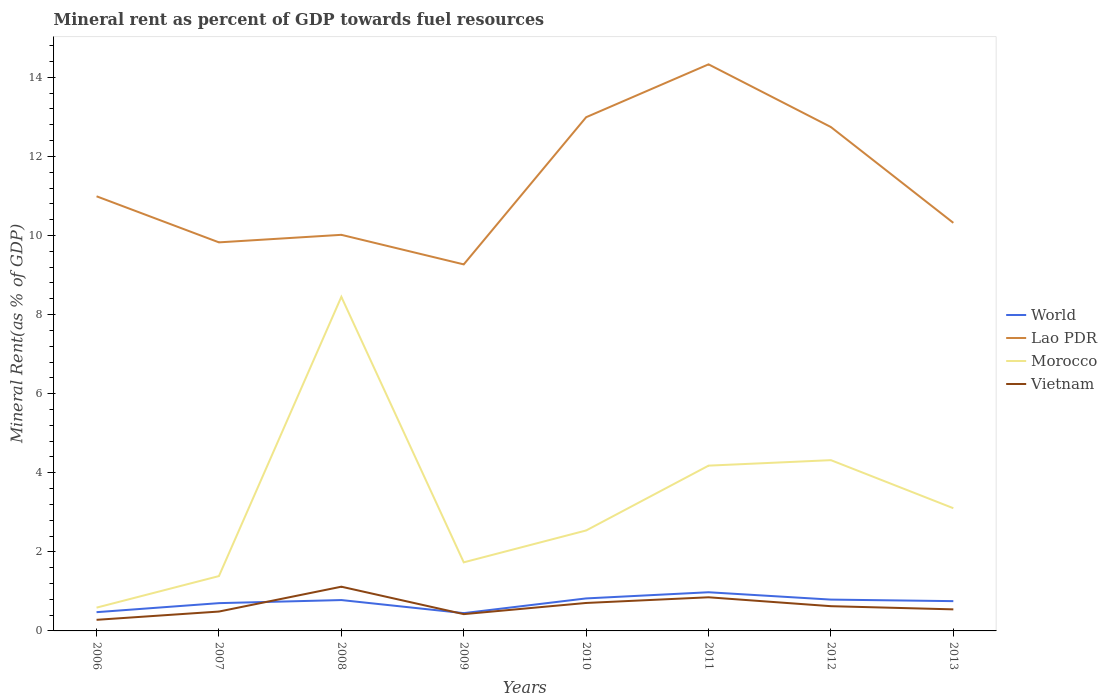How many different coloured lines are there?
Give a very brief answer. 4. Is the number of lines equal to the number of legend labels?
Make the answer very short. Yes. Across all years, what is the maximum mineral rent in Morocco?
Ensure brevity in your answer.  0.59. In which year was the mineral rent in Morocco maximum?
Your answer should be compact. 2006. What is the total mineral rent in Lao PDR in the graph?
Keep it short and to the point. -1.34. What is the difference between the highest and the second highest mineral rent in Morocco?
Your answer should be compact. 7.86. What is the difference between the highest and the lowest mineral rent in World?
Your response must be concise. 5. Is the mineral rent in Vietnam strictly greater than the mineral rent in Lao PDR over the years?
Keep it short and to the point. Yes. How many years are there in the graph?
Give a very brief answer. 8. Does the graph contain grids?
Offer a very short reply. No. How many legend labels are there?
Your answer should be very brief. 4. What is the title of the graph?
Offer a terse response. Mineral rent as percent of GDP towards fuel resources. What is the label or title of the X-axis?
Offer a very short reply. Years. What is the label or title of the Y-axis?
Give a very brief answer. Mineral Rent(as % of GDP). What is the Mineral Rent(as % of GDP) in World in 2006?
Ensure brevity in your answer.  0.47. What is the Mineral Rent(as % of GDP) of Lao PDR in 2006?
Offer a terse response. 10.99. What is the Mineral Rent(as % of GDP) of Morocco in 2006?
Your response must be concise. 0.59. What is the Mineral Rent(as % of GDP) of Vietnam in 2006?
Provide a short and direct response. 0.28. What is the Mineral Rent(as % of GDP) of World in 2007?
Keep it short and to the point. 0.7. What is the Mineral Rent(as % of GDP) of Lao PDR in 2007?
Provide a short and direct response. 9.83. What is the Mineral Rent(as % of GDP) in Morocco in 2007?
Ensure brevity in your answer.  1.39. What is the Mineral Rent(as % of GDP) of Vietnam in 2007?
Offer a terse response. 0.49. What is the Mineral Rent(as % of GDP) of World in 2008?
Your response must be concise. 0.78. What is the Mineral Rent(as % of GDP) of Lao PDR in 2008?
Make the answer very short. 10.02. What is the Mineral Rent(as % of GDP) in Morocco in 2008?
Your response must be concise. 8.45. What is the Mineral Rent(as % of GDP) of Vietnam in 2008?
Provide a short and direct response. 1.12. What is the Mineral Rent(as % of GDP) in World in 2009?
Your answer should be very brief. 0.45. What is the Mineral Rent(as % of GDP) of Lao PDR in 2009?
Provide a succinct answer. 9.27. What is the Mineral Rent(as % of GDP) of Morocco in 2009?
Your answer should be very brief. 1.73. What is the Mineral Rent(as % of GDP) in Vietnam in 2009?
Provide a short and direct response. 0.42. What is the Mineral Rent(as % of GDP) of World in 2010?
Keep it short and to the point. 0.82. What is the Mineral Rent(as % of GDP) in Lao PDR in 2010?
Offer a terse response. 12.99. What is the Mineral Rent(as % of GDP) in Morocco in 2010?
Keep it short and to the point. 2.54. What is the Mineral Rent(as % of GDP) of Vietnam in 2010?
Make the answer very short. 0.71. What is the Mineral Rent(as % of GDP) in World in 2011?
Keep it short and to the point. 0.98. What is the Mineral Rent(as % of GDP) in Lao PDR in 2011?
Ensure brevity in your answer.  14.33. What is the Mineral Rent(as % of GDP) of Morocco in 2011?
Make the answer very short. 4.18. What is the Mineral Rent(as % of GDP) of Vietnam in 2011?
Your answer should be very brief. 0.85. What is the Mineral Rent(as % of GDP) of World in 2012?
Make the answer very short. 0.79. What is the Mineral Rent(as % of GDP) in Lao PDR in 2012?
Give a very brief answer. 12.74. What is the Mineral Rent(as % of GDP) of Morocco in 2012?
Keep it short and to the point. 4.32. What is the Mineral Rent(as % of GDP) of Vietnam in 2012?
Offer a terse response. 0.63. What is the Mineral Rent(as % of GDP) of World in 2013?
Offer a very short reply. 0.75. What is the Mineral Rent(as % of GDP) in Lao PDR in 2013?
Make the answer very short. 10.32. What is the Mineral Rent(as % of GDP) in Morocco in 2013?
Your response must be concise. 3.1. What is the Mineral Rent(as % of GDP) of Vietnam in 2013?
Keep it short and to the point. 0.55. Across all years, what is the maximum Mineral Rent(as % of GDP) of World?
Provide a short and direct response. 0.98. Across all years, what is the maximum Mineral Rent(as % of GDP) of Lao PDR?
Your answer should be very brief. 14.33. Across all years, what is the maximum Mineral Rent(as % of GDP) of Morocco?
Make the answer very short. 8.45. Across all years, what is the maximum Mineral Rent(as % of GDP) in Vietnam?
Your answer should be compact. 1.12. Across all years, what is the minimum Mineral Rent(as % of GDP) in World?
Offer a terse response. 0.45. Across all years, what is the minimum Mineral Rent(as % of GDP) in Lao PDR?
Offer a very short reply. 9.27. Across all years, what is the minimum Mineral Rent(as % of GDP) in Morocco?
Ensure brevity in your answer.  0.59. Across all years, what is the minimum Mineral Rent(as % of GDP) of Vietnam?
Provide a short and direct response. 0.28. What is the total Mineral Rent(as % of GDP) of World in the graph?
Provide a short and direct response. 5.75. What is the total Mineral Rent(as % of GDP) of Lao PDR in the graph?
Offer a terse response. 90.48. What is the total Mineral Rent(as % of GDP) in Morocco in the graph?
Your answer should be very brief. 26.3. What is the total Mineral Rent(as % of GDP) of Vietnam in the graph?
Offer a terse response. 5.04. What is the difference between the Mineral Rent(as % of GDP) in World in 2006 and that in 2007?
Give a very brief answer. -0.23. What is the difference between the Mineral Rent(as % of GDP) in Lao PDR in 2006 and that in 2007?
Your answer should be compact. 1.16. What is the difference between the Mineral Rent(as % of GDP) of Morocco in 2006 and that in 2007?
Your answer should be compact. -0.8. What is the difference between the Mineral Rent(as % of GDP) of Vietnam in 2006 and that in 2007?
Make the answer very short. -0.21. What is the difference between the Mineral Rent(as % of GDP) of World in 2006 and that in 2008?
Provide a short and direct response. -0.31. What is the difference between the Mineral Rent(as % of GDP) in Lao PDR in 2006 and that in 2008?
Your answer should be compact. 0.97. What is the difference between the Mineral Rent(as % of GDP) of Morocco in 2006 and that in 2008?
Give a very brief answer. -7.86. What is the difference between the Mineral Rent(as % of GDP) in Vietnam in 2006 and that in 2008?
Provide a succinct answer. -0.84. What is the difference between the Mineral Rent(as % of GDP) of World in 2006 and that in 2009?
Provide a short and direct response. 0.02. What is the difference between the Mineral Rent(as % of GDP) of Lao PDR in 2006 and that in 2009?
Make the answer very short. 1.72. What is the difference between the Mineral Rent(as % of GDP) in Morocco in 2006 and that in 2009?
Ensure brevity in your answer.  -1.15. What is the difference between the Mineral Rent(as % of GDP) in Vietnam in 2006 and that in 2009?
Ensure brevity in your answer.  -0.14. What is the difference between the Mineral Rent(as % of GDP) in World in 2006 and that in 2010?
Provide a short and direct response. -0.35. What is the difference between the Mineral Rent(as % of GDP) in Lao PDR in 2006 and that in 2010?
Offer a very short reply. -2. What is the difference between the Mineral Rent(as % of GDP) in Morocco in 2006 and that in 2010?
Provide a succinct answer. -1.95. What is the difference between the Mineral Rent(as % of GDP) in Vietnam in 2006 and that in 2010?
Offer a terse response. -0.43. What is the difference between the Mineral Rent(as % of GDP) in World in 2006 and that in 2011?
Your answer should be very brief. -0.5. What is the difference between the Mineral Rent(as % of GDP) of Lao PDR in 2006 and that in 2011?
Offer a very short reply. -3.34. What is the difference between the Mineral Rent(as % of GDP) in Morocco in 2006 and that in 2011?
Ensure brevity in your answer.  -3.59. What is the difference between the Mineral Rent(as % of GDP) in Vietnam in 2006 and that in 2011?
Ensure brevity in your answer.  -0.57. What is the difference between the Mineral Rent(as % of GDP) in World in 2006 and that in 2012?
Ensure brevity in your answer.  -0.32. What is the difference between the Mineral Rent(as % of GDP) of Lao PDR in 2006 and that in 2012?
Keep it short and to the point. -1.75. What is the difference between the Mineral Rent(as % of GDP) of Morocco in 2006 and that in 2012?
Offer a terse response. -3.73. What is the difference between the Mineral Rent(as % of GDP) in Vietnam in 2006 and that in 2012?
Ensure brevity in your answer.  -0.34. What is the difference between the Mineral Rent(as % of GDP) of World in 2006 and that in 2013?
Offer a terse response. -0.28. What is the difference between the Mineral Rent(as % of GDP) of Lao PDR in 2006 and that in 2013?
Your response must be concise. 0.67. What is the difference between the Mineral Rent(as % of GDP) in Morocco in 2006 and that in 2013?
Provide a succinct answer. -2.51. What is the difference between the Mineral Rent(as % of GDP) of Vietnam in 2006 and that in 2013?
Provide a short and direct response. -0.26. What is the difference between the Mineral Rent(as % of GDP) of World in 2007 and that in 2008?
Ensure brevity in your answer.  -0.08. What is the difference between the Mineral Rent(as % of GDP) of Lao PDR in 2007 and that in 2008?
Make the answer very short. -0.19. What is the difference between the Mineral Rent(as % of GDP) in Morocco in 2007 and that in 2008?
Your response must be concise. -7.06. What is the difference between the Mineral Rent(as % of GDP) in Vietnam in 2007 and that in 2008?
Offer a very short reply. -0.63. What is the difference between the Mineral Rent(as % of GDP) in World in 2007 and that in 2009?
Keep it short and to the point. 0.25. What is the difference between the Mineral Rent(as % of GDP) of Lao PDR in 2007 and that in 2009?
Offer a very short reply. 0.56. What is the difference between the Mineral Rent(as % of GDP) of Morocco in 2007 and that in 2009?
Keep it short and to the point. -0.35. What is the difference between the Mineral Rent(as % of GDP) in Vietnam in 2007 and that in 2009?
Offer a terse response. 0.07. What is the difference between the Mineral Rent(as % of GDP) in World in 2007 and that in 2010?
Offer a terse response. -0.12. What is the difference between the Mineral Rent(as % of GDP) in Lao PDR in 2007 and that in 2010?
Ensure brevity in your answer.  -3.16. What is the difference between the Mineral Rent(as % of GDP) of Morocco in 2007 and that in 2010?
Provide a succinct answer. -1.15. What is the difference between the Mineral Rent(as % of GDP) of Vietnam in 2007 and that in 2010?
Provide a short and direct response. -0.22. What is the difference between the Mineral Rent(as % of GDP) in World in 2007 and that in 2011?
Give a very brief answer. -0.28. What is the difference between the Mineral Rent(as % of GDP) of Lao PDR in 2007 and that in 2011?
Give a very brief answer. -4.5. What is the difference between the Mineral Rent(as % of GDP) in Morocco in 2007 and that in 2011?
Keep it short and to the point. -2.79. What is the difference between the Mineral Rent(as % of GDP) of Vietnam in 2007 and that in 2011?
Provide a short and direct response. -0.36. What is the difference between the Mineral Rent(as % of GDP) of World in 2007 and that in 2012?
Provide a short and direct response. -0.09. What is the difference between the Mineral Rent(as % of GDP) in Lao PDR in 2007 and that in 2012?
Your answer should be compact. -2.92. What is the difference between the Mineral Rent(as % of GDP) in Morocco in 2007 and that in 2012?
Offer a very short reply. -2.93. What is the difference between the Mineral Rent(as % of GDP) of Vietnam in 2007 and that in 2012?
Your answer should be compact. -0.14. What is the difference between the Mineral Rent(as % of GDP) in World in 2007 and that in 2013?
Your answer should be compact. -0.05. What is the difference between the Mineral Rent(as % of GDP) in Lao PDR in 2007 and that in 2013?
Your answer should be compact. -0.49. What is the difference between the Mineral Rent(as % of GDP) in Morocco in 2007 and that in 2013?
Keep it short and to the point. -1.72. What is the difference between the Mineral Rent(as % of GDP) of Vietnam in 2007 and that in 2013?
Provide a succinct answer. -0.06. What is the difference between the Mineral Rent(as % of GDP) in World in 2008 and that in 2009?
Your answer should be very brief. 0.33. What is the difference between the Mineral Rent(as % of GDP) of Lao PDR in 2008 and that in 2009?
Make the answer very short. 0.75. What is the difference between the Mineral Rent(as % of GDP) of Morocco in 2008 and that in 2009?
Your answer should be very brief. 6.71. What is the difference between the Mineral Rent(as % of GDP) of Vietnam in 2008 and that in 2009?
Offer a very short reply. 0.69. What is the difference between the Mineral Rent(as % of GDP) of World in 2008 and that in 2010?
Your answer should be compact. -0.04. What is the difference between the Mineral Rent(as % of GDP) in Lao PDR in 2008 and that in 2010?
Provide a short and direct response. -2.97. What is the difference between the Mineral Rent(as % of GDP) in Morocco in 2008 and that in 2010?
Provide a short and direct response. 5.91. What is the difference between the Mineral Rent(as % of GDP) of Vietnam in 2008 and that in 2010?
Provide a short and direct response. 0.41. What is the difference between the Mineral Rent(as % of GDP) in World in 2008 and that in 2011?
Your response must be concise. -0.2. What is the difference between the Mineral Rent(as % of GDP) of Lao PDR in 2008 and that in 2011?
Keep it short and to the point. -4.31. What is the difference between the Mineral Rent(as % of GDP) of Morocco in 2008 and that in 2011?
Your answer should be very brief. 4.27. What is the difference between the Mineral Rent(as % of GDP) of Vietnam in 2008 and that in 2011?
Provide a succinct answer. 0.27. What is the difference between the Mineral Rent(as % of GDP) of World in 2008 and that in 2012?
Provide a succinct answer. -0.01. What is the difference between the Mineral Rent(as % of GDP) in Lao PDR in 2008 and that in 2012?
Make the answer very short. -2.73. What is the difference between the Mineral Rent(as % of GDP) in Morocco in 2008 and that in 2012?
Give a very brief answer. 4.13. What is the difference between the Mineral Rent(as % of GDP) in Vietnam in 2008 and that in 2012?
Your answer should be compact. 0.49. What is the difference between the Mineral Rent(as % of GDP) in World in 2008 and that in 2013?
Your response must be concise. 0.03. What is the difference between the Mineral Rent(as % of GDP) of Lao PDR in 2008 and that in 2013?
Your answer should be compact. -0.3. What is the difference between the Mineral Rent(as % of GDP) in Morocco in 2008 and that in 2013?
Provide a succinct answer. 5.35. What is the difference between the Mineral Rent(as % of GDP) in Vietnam in 2008 and that in 2013?
Keep it short and to the point. 0.57. What is the difference between the Mineral Rent(as % of GDP) of World in 2009 and that in 2010?
Your response must be concise. -0.37. What is the difference between the Mineral Rent(as % of GDP) of Lao PDR in 2009 and that in 2010?
Offer a very short reply. -3.72. What is the difference between the Mineral Rent(as % of GDP) in Morocco in 2009 and that in 2010?
Ensure brevity in your answer.  -0.81. What is the difference between the Mineral Rent(as % of GDP) in Vietnam in 2009 and that in 2010?
Your response must be concise. -0.28. What is the difference between the Mineral Rent(as % of GDP) of World in 2009 and that in 2011?
Your answer should be compact. -0.53. What is the difference between the Mineral Rent(as % of GDP) in Lao PDR in 2009 and that in 2011?
Provide a succinct answer. -5.06. What is the difference between the Mineral Rent(as % of GDP) of Morocco in 2009 and that in 2011?
Make the answer very short. -2.45. What is the difference between the Mineral Rent(as % of GDP) in Vietnam in 2009 and that in 2011?
Make the answer very short. -0.43. What is the difference between the Mineral Rent(as % of GDP) of World in 2009 and that in 2012?
Your answer should be very brief. -0.34. What is the difference between the Mineral Rent(as % of GDP) of Lao PDR in 2009 and that in 2012?
Offer a terse response. -3.47. What is the difference between the Mineral Rent(as % of GDP) of Morocco in 2009 and that in 2012?
Make the answer very short. -2.58. What is the difference between the Mineral Rent(as % of GDP) of Vietnam in 2009 and that in 2012?
Provide a short and direct response. -0.2. What is the difference between the Mineral Rent(as % of GDP) in World in 2009 and that in 2013?
Offer a terse response. -0.3. What is the difference between the Mineral Rent(as % of GDP) of Lao PDR in 2009 and that in 2013?
Offer a very short reply. -1.05. What is the difference between the Mineral Rent(as % of GDP) of Morocco in 2009 and that in 2013?
Your answer should be very brief. -1.37. What is the difference between the Mineral Rent(as % of GDP) in Vietnam in 2009 and that in 2013?
Your answer should be compact. -0.12. What is the difference between the Mineral Rent(as % of GDP) of World in 2010 and that in 2011?
Your answer should be very brief. -0.16. What is the difference between the Mineral Rent(as % of GDP) in Lao PDR in 2010 and that in 2011?
Your response must be concise. -1.34. What is the difference between the Mineral Rent(as % of GDP) in Morocco in 2010 and that in 2011?
Keep it short and to the point. -1.64. What is the difference between the Mineral Rent(as % of GDP) of Vietnam in 2010 and that in 2011?
Give a very brief answer. -0.14. What is the difference between the Mineral Rent(as % of GDP) in World in 2010 and that in 2012?
Make the answer very short. 0.03. What is the difference between the Mineral Rent(as % of GDP) of Lao PDR in 2010 and that in 2012?
Offer a terse response. 0.25. What is the difference between the Mineral Rent(as % of GDP) in Morocco in 2010 and that in 2012?
Provide a succinct answer. -1.78. What is the difference between the Mineral Rent(as % of GDP) in Vietnam in 2010 and that in 2012?
Provide a succinct answer. 0.08. What is the difference between the Mineral Rent(as % of GDP) of World in 2010 and that in 2013?
Ensure brevity in your answer.  0.07. What is the difference between the Mineral Rent(as % of GDP) of Lao PDR in 2010 and that in 2013?
Provide a short and direct response. 2.67. What is the difference between the Mineral Rent(as % of GDP) in Morocco in 2010 and that in 2013?
Ensure brevity in your answer.  -0.56. What is the difference between the Mineral Rent(as % of GDP) of Vietnam in 2010 and that in 2013?
Give a very brief answer. 0.16. What is the difference between the Mineral Rent(as % of GDP) of World in 2011 and that in 2012?
Provide a short and direct response. 0.19. What is the difference between the Mineral Rent(as % of GDP) of Lao PDR in 2011 and that in 2012?
Offer a very short reply. 1.59. What is the difference between the Mineral Rent(as % of GDP) of Morocco in 2011 and that in 2012?
Offer a very short reply. -0.14. What is the difference between the Mineral Rent(as % of GDP) of Vietnam in 2011 and that in 2012?
Provide a succinct answer. 0.22. What is the difference between the Mineral Rent(as % of GDP) in World in 2011 and that in 2013?
Offer a terse response. 0.22. What is the difference between the Mineral Rent(as % of GDP) in Lao PDR in 2011 and that in 2013?
Give a very brief answer. 4.01. What is the difference between the Mineral Rent(as % of GDP) in Morocco in 2011 and that in 2013?
Make the answer very short. 1.08. What is the difference between the Mineral Rent(as % of GDP) in Vietnam in 2011 and that in 2013?
Offer a very short reply. 0.31. What is the difference between the Mineral Rent(as % of GDP) of World in 2012 and that in 2013?
Your response must be concise. 0.04. What is the difference between the Mineral Rent(as % of GDP) of Lao PDR in 2012 and that in 2013?
Offer a terse response. 2.42. What is the difference between the Mineral Rent(as % of GDP) of Morocco in 2012 and that in 2013?
Offer a terse response. 1.22. What is the difference between the Mineral Rent(as % of GDP) of Vietnam in 2012 and that in 2013?
Keep it short and to the point. 0.08. What is the difference between the Mineral Rent(as % of GDP) of World in 2006 and the Mineral Rent(as % of GDP) of Lao PDR in 2007?
Your answer should be compact. -9.35. What is the difference between the Mineral Rent(as % of GDP) in World in 2006 and the Mineral Rent(as % of GDP) in Morocco in 2007?
Your answer should be compact. -0.91. What is the difference between the Mineral Rent(as % of GDP) of World in 2006 and the Mineral Rent(as % of GDP) of Vietnam in 2007?
Your response must be concise. -0.02. What is the difference between the Mineral Rent(as % of GDP) in Lao PDR in 2006 and the Mineral Rent(as % of GDP) in Morocco in 2007?
Keep it short and to the point. 9.6. What is the difference between the Mineral Rent(as % of GDP) in Lao PDR in 2006 and the Mineral Rent(as % of GDP) in Vietnam in 2007?
Make the answer very short. 10.5. What is the difference between the Mineral Rent(as % of GDP) in Morocco in 2006 and the Mineral Rent(as % of GDP) in Vietnam in 2007?
Offer a very short reply. 0.1. What is the difference between the Mineral Rent(as % of GDP) of World in 2006 and the Mineral Rent(as % of GDP) of Lao PDR in 2008?
Offer a terse response. -9.54. What is the difference between the Mineral Rent(as % of GDP) in World in 2006 and the Mineral Rent(as % of GDP) in Morocco in 2008?
Your answer should be very brief. -7.97. What is the difference between the Mineral Rent(as % of GDP) of World in 2006 and the Mineral Rent(as % of GDP) of Vietnam in 2008?
Give a very brief answer. -0.64. What is the difference between the Mineral Rent(as % of GDP) in Lao PDR in 2006 and the Mineral Rent(as % of GDP) in Morocco in 2008?
Offer a terse response. 2.54. What is the difference between the Mineral Rent(as % of GDP) in Lao PDR in 2006 and the Mineral Rent(as % of GDP) in Vietnam in 2008?
Your answer should be compact. 9.87. What is the difference between the Mineral Rent(as % of GDP) in Morocco in 2006 and the Mineral Rent(as % of GDP) in Vietnam in 2008?
Make the answer very short. -0.53. What is the difference between the Mineral Rent(as % of GDP) of World in 2006 and the Mineral Rent(as % of GDP) of Lao PDR in 2009?
Make the answer very short. -8.79. What is the difference between the Mineral Rent(as % of GDP) of World in 2006 and the Mineral Rent(as % of GDP) of Morocco in 2009?
Give a very brief answer. -1.26. What is the difference between the Mineral Rent(as % of GDP) of World in 2006 and the Mineral Rent(as % of GDP) of Vietnam in 2009?
Your answer should be very brief. 0.05. What is the difference between the Mineral Rent(as % of GDP) of Lao PDR in 2006 and the Mineral Rent(as % of GDP) of Morocco in 2009?
Ensure brevity in your answer.  9.26. What is the difference between the Mineral Rent(as % of GDP) in Lao PDR in 2006 and the Mineral Rent(as % of GDP) in Vietnam in 2009?
Offer a very short reply. 10.57. What is the difference between the Mineral Rent(as % of GDP) of Morocco in 2006 and the Mineral Rent(as % of GDP) of Vietnam in 2009?
Provide a short and direct response. 0.16. What is the difference between the Mineral Rent(as % of GDP) of World in 2006 and the Mineral Rent(as % of GDP) of Lao PDR in 2010?
Offer a terse response. -12.52. What is the difference between the Mineral Rent(as % of GDP) in World in 2006 and the Mineral Rent(as % of GDP) in Morocco in 2010?
Provide a succinct answer. -2.07. What is the difference between the Mineral Rent(as % of GDP) in World in 2006 and the Mineral Rent(as % of GDP) in Vietnam in 2010?
Ensure brevity in your answer.  -0.23. What is the difference between the Mineral Rent(as % of GDP) of Lao PDR in 2006 and the Mineral Rent(as % of GDP) of Morocco in 2010?
Make the answer very short. 8.45. What is the difference between the Mineral Rent(as % of GDP) of Lao PDR in 2006 and the Mineral Rent(as % of GDP) of Vietnam in 2010?
Provide a short and direct response. 10.28. What is the difference between the Mineral Rent(as % of GDP) of Morocco in 2006 and the Mineral Rent(as % of GDP) of Vietnam in 2010?
Your answer should be compact. -0.12. What is the difference between the Mineral Rent(as % of GDP) in World in 2006 and the Mineral Rent(as % of GDP) in Lao PDR in 2011?
Your response must be concise. -13.85. What is the difference between the Mineral Rent(as % of GDP) of World in 2006 and the Mineral Rent(as % of GDP) of Morocco in 2011?
Give a very brief answer. -3.71. What is the difference between the Mineral Rent(as % of GDP) of World in 2006 and the Mineral Rent(as % of GDP) of Vietnam in 2011?
Make the answer very short. -0.38. What is the difference between the Mineral Rent(as % of GDP) in Lao PDR in 2006 and the Mineral Rent(as % of GDP) in Morocco in 2011?
Your answer should be compact. 6.81. What is the difference between the Mineral Rent(as % of GDP) in Lao PDR in 2006 and the Mineral Rent(as % of GDP) in Vietnam in 2011?
Provide a succinct answer. 10.14. What is the difference between the Mineral Rent(as % of GDP) in Morocco in 2006 and the Mineral Rent(as % of GDP) in Vietnam in 2011?
Keep it short and to the point. -0.26. What is the difference between the Mineral Rent(as % of GDP) of World in 2006 and the Mineral Rent(as % of GDP) of Lao PDR in 2012?
Give a very brief answer. -12.27. What is the difference between the Mineral Rent(as % of GDP) in World in 2006 and the Mineral Rent(as % of GDP) in Morocco in 2012?
Your answer should be very brief. -3.84. What is the difference between the Mineral Rent(as % of GDP) in World in 2006 and the Mineral Rent(as % of GDP) in Vietnam in 2012?
Your answer should be compact. -0.15. What is the difference between the Mineral Rent(as % of GDP) of Lao PDR in 2006 and the Mineral Rent(as % of GDP) of Morocco in 2012?
Provide a succinct answer. 6.67. What is the difference between the Mineral Rent(as % of GDP) of Lao PDR in 2006 and the Mineral Rent(as % of GDP) of Vietnam in 2012?
Your answer should be compact. 10.37. What is the difference between the Mineral Rent(as % of GDP) in Morocco in 2006 and the Mineral Rent(as % of GDP) in Vietnam in 2012?
Provide a succinct answer. -0.04. What is the difference between the Mineral Rent(as % of GDP) in World in 2006 and the Mineral Rent(as % of GDP) in Lao PDR in 2013?
Your response must be concise. -9.85. What is the difference between the Mineral Rent(as % of GDP) of World in 2006 and the Mineral Rent(as % of GDP) of Morocco in 2013?
Offer a very short reply. -2.63. What is the difference between the Mineral Rent(as % of GDP) in World in 2006 and the Mineral Rent(as % of GDP) in Vietnam in 2013?
Your answer should be very brief. -0.07. What is the difference between the Mineral Rent(as % of GDP) of Lao PDR in 2006 and the Mineral Rent(as % of GDP) of Morocco in 2013?
Make the answer very short. 7.89. What is the difference between the Mineral Rent(as % of GDP) of Lao PDR in 2006 and the Mineral Rent(as % of GDP) of Vietnam in 2013?
Offer a terse response. 10.45. What is the difference between the Mineral Rent(as % of GDP) in Morocco in 2006 and the Mineral Rent(as % of GDP) in Vietnam in 2013?
Provide a succinct answer. 0.04. What is the difference between the Mineral Rent(as % of GDP) in World in 2007 and the Mineral Rent(as % of GDP) in Lao PDR in 2008?
Your answer should be very brief. -9.31. What is the difference between the Mineral Rent(as % of GDP) of World in 2007 and the Mineral Rent(as % of GDP) of Morocco in 2008?
Give a very brief answer. -7.75. What is the difference between the Mineral Rent(as % of GDP) of World in 2007 and the Mineral Rent(as % of GDP) of Vietnam in 2008?
Keep it short and to the point. -0.42. What is the difference between the Mineral Rent(as % of GDP) in Lao PDR in 2007 and the Mineral Rent(as % of GDP) in Morocco in 2008?
Your response must be concise. 1.38. What is the difference between the Mineral Rent(as % of GDP) of Lao PDR in 2007 and the Mineral Rent(as % of GDP) of Vietnam in 2008?
Provide a short and direct response. 8.71. What is the difference between the Mineral Rent(as % of GDP) in Morocco in 2007 and the Mineral Rent(as % of GDP) in Vietnam in 2008?
Your answer should be very brief. 0.27. What is the difference between the Mineral Rent(as % of GDP) in World in 2007 and the Mineral Rent(as % of GDP) in Lao PDR in 2009?
Make the answer very short. -8.57. What is the difference between the Mineral Rent(as % of GDP) of World in 2007 and the Mineral Rent(as % of GDP) of Morocco in 2009?
Keep it short and to the point. -1.03. What is the difference between the Mineral Rent(as % of GDP) in World in 2007 and the Mineral Rent(as % of GDP) in Vietnam in 2009?
Offer a terse response. 0.28. What is the difference between the Mineral Rent(as % of GDP) of Lao PDR in 2007 and the Mineral Rent(as % of GDP) of Morocco in 2009?
Your answer should be very brief. 8.09. What is the difference between the Mineral Rent(as % of GDP) of Lao PDR in 2007 and the Mineral Rent(as % of GDP) of Vietnam in 2009?
Give a very brief answer. 9.4. What is the difference between the Mineral Rent(as % of GDP) of Morocco in 2007 and the Mineral Rent(as % of GDP) of Vietnam in 2009?
Give a very brief answer. 0.96. What is the difference between the Mineral Rent(as % of GDP) in World in 2007 and the Mineral Rent(as % of GDP) in Lao PDR in 2010?
Your answer should be very brief. -12.29. What is the difference between the Mineral Rent(as % of GDP) of World in 2007 and the Mineral Rent(as % of GDP) of Morocco in 2010?
Your response must be concise. -1.84. What is the difference between the Mineral Rent(as % of GDP) in World in 2007 and the Mineral Rent(as % of GDP) in Vietnam in 2010?
Your answer should be very brief. -0. What is the difference between the Mineral Rent(as % of GDP) of Lao PDR in 2007 and the Mineral Rent(as % of GDP) of Morocco in 2010?
Provide a succinct answer. 7.29. What is the difference between the Mineral Rent(as % of GDP) of Lao PDR in 2007 and the Mineral Rent(as % of GDP) of Vietnam in 2010?
Your answer should be compact. 9.12. What is the difference between the Mineral Rent(as % of GDP) of Morocco in 2007 and the Mineral Rent(as % of GDP) of Vietnam in 2010?
Make the answer very short. 0.68. What is the difference between the Mineral Rent(as % of GDP) of World in 2007 and the Mineral Rent(as % of GDP) of Lao PDR in 2011?
Give a very brief answer. -13.63. What is the difference between the Mineral Rent(as % of GDP) of World in 2007 and the Mineral Rent(as % of GDP) of Morocco in 2011?
Provide a succinct answer. -3.48. What is the difference between the Mineral Rent(as % of GDP) in World in 2007 and the Mineral Rent(as % of GDP) in Vietnam in 2011?
Give a very brief answer. -0.15. What is the difference between the Mineral Rent(as % of GDP) of Lao PDR in 2007 and the Mineral Rent(as % of GDP) of Morocco in 2011?
Offer a very short reply. 5.65. What is the difference between the Mineral Rent(as % of GDP) in Lao PDR in 2007 and the Mineral Rent(as % of GDP) in Vietnam in 2011?
Your answer should be very brief. 8.98. What is the difference between the Mineral Rent(as % of GDP) in Morocco in 2007 and the Mineral Rent(as % of GDP) in Vietnam in 2011?
Offer a terse response. 0.54. What is the difference between the Mineral Rent(as % of GDP) of World in 2007 and the Mineral Rent(as % of GDP) of Lao PDR in 2012?
Make the answer very short. -12.04. What is the difference between the Mineral Rent(as % of GDP) in World in 2007 and the Mineral Rent(as % of GDP) in Morocco in 2012?
Your answer should be compact. -3.62. What is the difference between the Mineral Rent(as % of GDP) of World in 2007 and the Mineral Rent(as % of GDP) of Vietnam in 2012?
Offer a terse response. 0.08. What is the difference between the Mineral Rent(as % of GDP) of Lao PDR in 2007 and the Mineral Rent(as % of GDP) of Morocco in 2012?
Offer a very short reply. 5.51. What is the difference between the Mineral Rent(as % of GDP) in Lao PDR in 2007 and the Mineral Rent(as % of GDP) in Vietnam in 2012?
Your answer should be very brief. 9.2. What is the difference between the Mineral Rent(as % of GDP) in Morocco in 2007 and the Mineral Rent(as % of GDP) in Vietnam in 2012?
Your response must be concise. 0.76. What is the difference between the Mineral Rent(as % of GDP) of World in 2007 and the Mineral Rent(as % of GDP) of Lao PDR in 2013?
Your answer should be compact. -9.62. What is the difference between the Mineral Rent(as % of GDP) of World in 2007 and the Mineral Rent(as % of GDP) of Morocco in 2013?
Keep it short and to the point. -2.4. What is the difference between the Mineral Rent(as % of GDP) in World in 2007 and the Mineral Rent(as % of GDP) in Vietnam in 2013?
Ensure brevity in your answer.  0.16. What is the difference between the Mineral Rent(as % of GDP) in Lao PDR in 2007 and the Mineral Rent(as % of GDP) in Morocco in 2013?
Offer a terse response. 6.72. What is the difference between the Mineral Rent(as % of GDP) in Lao PDR in 2007 and the Mineral Rent(as % of GDP) in Vietnam in 2013?
Give a very brief answer. 9.28. What is the difference between the Mineral Rent(as % of GDP) of Morocco in 2007 and the Mineral Rent(as % of GDP) of Vietnam in 2013?
Keep it short and to the point. 0.84. What is the difference between the Mineral Rent(as % of GDP) in World in 2008 and the Mineral Rent(as % of GDP) in Lao PDR in 2009?
Your answer should be very brief. -8.49. What is the difference between the Mineral Rent(as % of GDP) in World in 2008 and the Mineral Rent(as % of GDP) in Morocco in 2009?
Provide a short and direct response. -0.95. What is the difference between the Mineral Rent(as % of GDP) in World in 2008 and the Mineral Rent(as % of GDP) in Vietnam in 2009?
Provide a succinct answer. 0.36. What is the difference between the Mineral Rent(as % of GDP) in Lao PDR in 2008 and the Mineral Rent(as % of GDP) in Morocco in 2009?
Your response must be concise. 8.28. What is the difference between the Mineral Rent(as % of GDP) in Lao PDR in 2008 and the Mineral Rent(as % of GDP) in Vietnam in 2009?
Your answer should be very brief. 9.59. What is the difference between the Mineral Rent(as % of GDP) in Morocco in 2008 and the Mineral Rent(as % of GDP) in Vietnam in 2009?
Provide a succinct answer. 8.02. What is the difference between the Mineral Rent(as % of GDP) in World in 2008 and the Mineral Rent(as % of GDP) in Lao PDR in 2010?
Ensure brevity in your answer.  -12.21. What is the difference between the Mineral Rent(as % of GDP) of World in 2008 and the Mineral Rent(as % of GDP) of Morocco in 2010?
Your answer should be compact. -1.76. What is the difference between the Mineral Rent(as % of GDP) of World in 2008 and the Mineral Rent(as % of GDP) of Vietnam in 2010?
Your answer should be compact. 0.07. What is the difference between the Mineral Rent(as % of GDP) of Lao PDR in 2008 and the Mineral Rent(as % of GDP) of Morocco in 2010?
Give a very brief answer. 7.48. What is the difference between the Mineral Rent(as % of GDP) of Lao PDR in 2008 and the Mineral Rent(as % of GDP) of Vietnam in 2010?
Offer a terse response. 9.31. What is the difference between the Mineral Rent(as % of GDP) of Morocco in 2008 and the Mineral Rent(as % of GDP) of Vietnam in 2010?
Provide a short and direct response. 7.74. What is the difference between the Mineral Rent(as % of GDP) in World in 2008 and the Mineral Rent(as % of GDP) in Lao PDR in 2011?
Make the answer very short. -13.55. What is the difference between the Mineral Rent(as % of GDP) in World in 2008 and the Mineral Rent(as % of GDP) in Morocco in 2011?
Your response must be concise. -3.4. What is the difference between the Mineral Rent(as % of GDP) of World in 2008 and the Mineral Rent(as % of GDP) of Vietnam in 2011?
Make the answer very short. -0.07. What is the difference between the Mineral Rent(as % of GDP) of Lao PDR in 2008 and the Mineral Rent(as % of GDP) of Morocco in 2011?
Your response must be concise. 5.84. What is the difference between the Mineral Rent(as % of GDP) in Lao PDR in 2008 and the Mineral Rent(as % of GDP) in Vietnam in 2011?
Give a very brief answer. 9.17. What is the difference between the Mineral Rent(as % of GDP) of Morocco in 2008 and the Mineral Rent(as % of GDP) of Vietnam in 2011?
Provide a short and direct response. 7.6. What is the difference between the Mineral Rent(as % of GDP) of World in 2008 and the Mineral Rent(as % of GDP) of Lao PDR in 2012?
Provide a succinct answer. -11.96. What is the difference between the Mineral Rent(as % of GDP) in World in 2008 and the Mineral Rent(as % of GDP) in Morocco in 2012?
Keep it short and to the point. -3.54. What is the difference between the Mineral Rent(as % of GDP) of World in 2008 and the Mineral Rent(as % of GDP) of Vietnam in 2012?
Your answer should be compact. 0.15. What is the difference between the Mineral Rent(as % of GDP) in Lao PDR in 2008 and the Mineral Rent(as % of GDP) in Morocco in 2012?
Offer a terse response. 5.7. What is the difference between the Mineral Rent(as % of GDP) in Lao PDR in 2008 and the Mineral Rent(as % of GDP) in Vietnam in 2012?
Your response must be concise. 9.39. What is the difference between the Mineral Rent(as % of GDP) of Morocco in 2008 and the Mineral Rent(as % of GDP) of Vietnam in 2012?
Give a very brief answer. 7.82. What is the difference between the Mineral Rent(as % of GDP) in World in 2008 and the Mineral Rent(as % of GDP) in Lao PDR in 2013?
Keep it short and to the point. -9.54. What is the difference between the Mineral Rent(as % of GDP) in World in 2008 and the Mineral Rent(as % of GDP) in Morocco in 2013?
Your answer should be very brief. -2.32. What is the difference between the Mineral Rent(as % of GDP) of World in 2008 and the Mineral Rent(as % of GDP) of Vietnam in 2013?
Offer a very short reply. 0.24. What is the difference between the Mineral Rent(as % of GDP) in Lao PDR in 2008 and the Mineral Rent(as % of GDP) in Morocco in 2013?
Your answer should be compact. 6.91. What is the difference between the Mineral Rent(as % of GDP) in Lao PDR in 2008 and the Mineral Rent(as % of GDP) in Vietnam in 2013?
Your answer should be very brief. 9.47. What is the difference between the Mineral Rent(as % of GDP) of Morocco in 2008 and the Mineral Rent(as % of GDP) of Vietnam in 2013?
Your answer should be compact. 7.9. What is the difference between the Mineral Rent(as % of GDP) in World in 2009 and the Mineral Rent(as % of GDP) in Lao PDR in 2010?
Give a very brief answer. -12.54. What is the difference between the Mineral Rent(as % of GDP) of World in 2009 and the Mineral Rent(as % of GDP) of Morocco in 2010?
Keep it short and to the point. -2.09. What is the difference between the Mineral Rent(as % of GDP) of World in 2009 and the Mineral Rent(as % of GDP) of Vietnam in 2010?
Your answer should be very brief. -0.26. What is the difference between the Mineral Rent(as % of GDP) of Lao PDR in 2009 and the Mineral Rent(as % of GDP) of Morocco in 2010?
Ensure brevity in your answer.  6.73. What is the difference between the Mineral Rent(as % of GDP) of Lao PDR in 2009 and the Mineral Rent(as % of GDP) of Vietnam in 2010?
Offer a very short reply. 8.56. What is the difference between the Mineral Rent(as % of GDP) of Morocco in 2009 and the Mineral Rent(as % of GDP) of Vietnam in 2010?
Keep it short and to the point. 1.03. What is the difference between the Mineral Rent(as % of GDP) in World in 2009 and the Mineral Rent(as % of GDP) in Lao PDR in 2011?
Provide a short and direct response. -13.88. What is the difference between the Mineral Rent(as % of GDP) of World in 2009 and the Mineral Rent(as % of GDP) of Morocco in 2011?
Provide a succinct answer. -3.73. What is the difference between the Mineral Rent(as % of GDP) of World in 2009 and the Mineral Rent(as % of GDP) of Vietnam in 2011?
Keep it short and to the point. -0.4. What is the difference between the Mineral Rent(as % of GDP) in Lao PDR in 2009 and the Mineral Rent(as % of GDP) in Morocco in 2011?
Offer a very short reply. 5.09. What is the difference between the Mineral Rent(as % of GDP) of Lao PDR in 2009 and the Mineral Rent(as % of GDP) of Vietnam in 2011?
Your answer should be very brief. 8.42. What is the difference between the Mineral Rent(as % of GDP) of Morocco in 2009 and the Mineral Rent(as % of GDP) of Vietnam in 2011?
Give a very brief answer. 0.88. What is the difference between the Mineral Rent(as % of GDP) of World in 2009 and the Mineral Rent(as % of GDP) of Lao PDR in 2012?
Give a very brief answer. -12.29. What is the difference between the Mineral Rent(as % of GDP) of World in 2009 and the Mineral Rent(as % of GDP) of Morocco in 2012?
Keep it short and to the point. -3.87. What is the difference between the Mineral Rent(as % of GDP) in World in 2009 and the Mineral Rent(as % of GDP) in Vietnam in 2012?
Offer a terse response. -0.18. What is the difference between the Mineral Rent(as % of GDP) in Lao PDR in 2009 and the Mineral Rent(as % of GDP) in Morocco in 2012?
Give a very brief answer. 4.95. What is the difference between the Mineral Rent(as % of GDP) in Lao PDR in 2009 and the Mineral Rent(as % of GDP) in Vietnam in 2012?
Your answer should be compact. 8.64. What is the difference between the Mineral Rent(as % of GDP) of Morocco in 2009 and the Mineral Rent(as % of GDP) of Vietnam in 2012?
Offer a terse response. 1.11. What is the difference between the Mineral Rent(as % of GDP) in World in 2009 and the Mineral Rent(as % of GDP) in Lao PDR in 2013?
Your answer should be very brief. -9.87. What is the difference between the Mineral Rent(as % of GDP) of World in 2009 and the Mineral Rent(as % of GDP) of Morocco in 2013?
Keep it short and to the point. -2.65. What is the difference between the Mineral Rent(as % of GDP) in World in 2009 and the Mineral Rent(as % of GDP) in Vietnam in 2013?
Ensure brevity in your answer.  -0.1. What is the difference between the Mineral Rent(as % of GDP) in Lao PDR in 2009 and the Mineral Rent(as % of GDP) in Morocco in 2013?
Your response must be concise. 6.17. What is the difference between the Mineral Rent(as % of GDP) in Lao PDR in 2009 and the Mineral Rent(as % of GDP) in Vietnam in 2013?
Ensure brevity in your answer.  8.72. What is the difference between the Mineral Rent(as % of GDP) in Morocco in 2009 and the Mineral Rent(as % of GDP) in Vietnam in 2013?
Make the answer very short. 1.19. What is the difference between the Mineral Rent(as % of GDP) of World in 2010 and the Mineral Rent(as % of GDP) of Lao PDR in 2011?
Make the answer very short. -13.51. What is the difference between the Mineral Rent(as % of GDP) in World in 2010 and the Mineral Rent(as % of GDP) in Morocco in 2011?
Your answer should be compact. -3.36. What is the difference between the Mineral Rent(as % of GDP) of World in 2010 and the Mineral Rent(as % of GDP) of Vietnam in 2011?
Give a very brief answer. -0.03. What is the difference between the Mineral Rent(as % of GDP) in Lao PDR in 2010 and the Mineral Rent(as % of GDP) in Morocco in 2011?
Ensure brevity in your answer.  8.81. What is the difference between the Mineral Rent(as % of GDP) of Lao PDR in 2010 and the Mineral Rent(as % of GDP) of Vietnam in 2011?
Make the answer very short. 12.14. What is the difference between the Mineral Rent(as % of GDP) in Morocco in 2010 and the Mineral Rent(as % of GDP) in Vietnam in 2011?
Your answer should be very brief. 1.69. What is the difference between the Mineral Rent(as % of GDP) in World in 2010 and the Mineral Rent(as % of GDP) in Lao PDR in 2012?
Give a very brief answer. -11.92. What is the difference between the Mineral Rent(as % of GDP) of World in 2010 and the Mineral Rent(as % of GDP) of Morocco in 2012?
Ensure brevity in your answer.  -3.5. What is the difference between the Mineral Rent(as % of GDP) of World in 2010 and the Mineral Rent(as % of GDP) of Vietnam in 2012?
Keep it short and to the point. 0.2. What is the difference between the Mineral Rent(as % of GDP) in Lao PDR in 2010 and the Mineral Rent(as % of GDP) in Morocco in 2012?
Provide a succinct answer. 8.67. What is the difference between the Mineral Rent(as % of GDP) in Lao PDR in 2010 and the Mineral Rent(as % of GDP) in Vietnam in 2012?
Offer a terse response. 12.37. What is the difference between the Mineral Rent(as % of GDP) in Morocco in 2010 and the Mineral Rent(as % of GDP) in Vietnam in 2012?
Give a very brief answer. 1.91. What is the difference between the Mineral Rent(as % of GDP) in World in 2010 and the Mineral Rent(as % of GDP) in Lao PDR in 2013?
Your answer should be compact. -9.5. What is the difference between the Mineral Rent(as % of GDP) in World in 2010 and the Mineral Rent(as % of GDP) in Morocco in 2013?
Provide a succinct answer. -2.28. What is the difference between the Mineral Rent(as % of GDP) of World in 2010 and the Mineral Rent(as % of GDP) of Vietnam in 2013?
Offer a very short reply. 0.28. What is the difference between the Mineral Rent(as % of GDP) of Lao PDR in 2010 and the Mineral Rent(as % of GDP) of Morocco in 2013?
Give a very brief answer. 9.89. What is the difference between the Mineral Rent(as % of GDP) in Lao PDR in 2010 and the Mineral Rent(as % of GDP) in Vietnam in 2013?
Make the answer very short. 12.45. What is the difference between the Mineral Rent(as % of GDP) in Morocco in 2010 and the Mineral Rent(as % of GDP) in Vietnam in 2013?
Give a very brief answer. 1.99. What is the difference between the Mineral Rent(as % of GDP) of World in 2011 and the Mineral Rent(as % of GDP) of Lao PDR in 2012?
Ensure brevity in your answer.  -11.76. What is the difference between the Mineral Rent(as % of GDP) in World in 2011 and the Mineral Rent(as % of GDP) in Morocco in 2012?
Keep it short and to the point. -3.34. What is the difference between the Mineral Rent(as % of GDP) of World in 2011 and the Mineral Rent(as % of GDP) of Vietnam in 2012?
Offer a terse response. 0.35. What is the difference between the Mineral Rent(as % of GDP) of Lao PDR in 2011 and the Mineral Rent(as % of GDP) of Morocco in 2012?
Provide a succinct answer. 10.01. What is the difference between the Mineral Rent(as % of GDP) in Lao PDR in 2011 and the Mineral Rent(as % of GDP) in Vietnam in 2012?
Your response must be concise. 13.7. What is the difference between the Mineral Rent(as % of GDP) in Morocco in 2011 and the Mineral Rent(as % of GDP) in Vietnam in 2012?
Make the answer very short. 3.55. What is the difference between the Mineral Rent(as % of GDP) of World in 2011 and the Mineral Rent(as % of GDP) of Lao PDR in 2013?
Offer a very short reply. -9.34. What is the difference between the Mineral Rent(as % of GDP) in World in 2011 and the Mineral Rent(as % of GDP) in Morocco in 2013?
Your answer should be compact. -2.13. What is the difference between the Mineral Rent(as % of GDP) of World in 2011 and the Mineral Rent(as % of GDP) of Vietnam in 2013?
Make the answer very short. 0.43. What is the difference between the Mineral Rent(as % of GDP) in Lao PDR in 2011 and the Mineral Rent(as % of GDP) in Morocco in 2013?
Keep it short and to the point. 11.22. What is the difference between the Mineral Rent(as % of GDP) of Lao PDR in 2011 and the Mineral Rent(as % of GDP) of Vietnam in 2013?
Provide a succinct answer. 13.78. What is the difference between the Mineral Rent(as % of GDP) of Morocco in 2011 and the Mineral Rent(as % of GDP) of Vietnam in 2013?
Offer a very short reply. 3.63. What is the difference between the Mineral Rent(as % of GDP) of World in 2012 and the Mineral Rent(as % of GDP) of Lao PDR in 2013?
Give a very brief answer. -9.53. What is the difference between the Mineral Rent(as % of GDP) of World in 2012 and the Mineral Rent(as % of GDP) of Morocco in 2013?
Provide a succinct answer. -2.31. What is the difference between the Mineral Rent(as % of GDP) of World in 2012 and the Mineral Rent(as % of GDP) of Vietnam in 2013?
Your response must be concise. 0.25. What is the difference between the Mineral Rent(as % of GDP) in Lao PDR in 2012 and the Mineral Rent(as % of GDP) in Morocco in 2013?
Your answer should be compact. 9.64. What is the difference between the Mineral Rent(as % of GDP) in Lao PDR in 2012 and the Mineral Rent(as % of GDP) in Vietnam in 2013?
Provide a succinct answer. 12.2. What is the difference between the Mineral Rent(as % of GDP) of Morocco in 2012 and the Mineral Rent(as % of GDP) of Vietnam in 2013?
Offer a terse response. 3.77. What is the average Mineral Rent(as % of GDP) in World per year?
Your response must be concise. 0.72. What is the average Mineral Rent(as % of GDP) in Lao PDR per year?
Your answer should be very brief. 11.31. What is the average Mineral Rent(as % of GDP) in Morocco per year?
Your answer should be compact. 3.29. What is the average Mineral Rent(as % of GDP) in Vietnam per year?
Your response must be concise. 0.63. In the year 2006, what is the difference between the Mineral Rent(as % of GDP) of World and Mineral Rent(as % of GDP) of Lao PDR?
Offer a terse response. -10.52. In the year 2006, what is the difference between the Mineral Rent(as % of GDP) of World and Mineral Rent(as % of GDP) of Morocco?
Make the answer very short. -0.11. In the year 2006, what is the difference between the Mineral Rent(as % of GDP) of World and Mineral Rent(as % of GDP) of Vietnam?
Keep it short and to the point. 0.19. In the year 2006, what is the difference between the Mineral Rent(as % of GDP) of Lao PDR and Mineral Rent(as % of GDP) of Morocco?
Make the answer very short. 10.4. In the year 2006, what is the difference between the Mineral Rent(as % of GDP) of Lao PDR and Mineral Rent(as % of GDP) of Vietnam?
Your answer should be compact. 10.71. In the year 2006, what is the difference between the Mineral Rent(as % of GDP) in Morocco and Mineral Rent(as % of GDP) in Vietnam?
Your answer should be very brief. 0.31. In the year 2007, what is the difference between the Mineral Rent(as % of GDP) in World and Mineral Rent(as % of GDP) in Lao PDR?
Offer a terse response. -9.12. In the year 2007, what is the difference between the Mineral Rent(as % of GDP) in World and Mineral Rent(as % of GDP) in Morocco?
Your response must be concise. -0.68. In the year 2007, what is the difference between the Mineral Rent(as % of GDP) of World and Mineral Rent(as % of GDP) of Vietnam?
Your response must be concise. 0.21. In the year 2007, what is the difference between the Mineral Rent(as % of GDP) in Lao PDR and Mineral Rent(as % of GDP) in Morocco?
Provide a short and direct response. 8.44. In the year 2007, what is the difference between the Mineral Rent(as % of GDP) in Lao PDR and Mineral Rent(as % of GDP) in Vietnam?
Make the answer very short. 9.34. In the year 2007, what is the difference between the Mineral Rent(as % of GDP) of Morocco and Mineral Rent(as % of GDP) of Vietnam?
Your response must be concise. 0.9. In the year 2008, what is the difference between the Mineral Rent(as % of GDP) of World and Mineral Rent(as % of GDP) of Lao PDR?
Give a very brief answer. -9.24. In the year 2008, what is the difference between the Mineral Rent(as % of GDP) in World and Mineral Rent(as % of GDP) in Morocco?
Offer a terse response. -7.67. In the year 2008, what is the difference between the Mineral Rent(as % of GDP) of World and Mineral Rent(as % of GDP) of Vietnam?
Offer a very short reply. -0.34. In the year 2008, what is the difference between the Mineral Rent(as % of GDP) of Lao PDR and Mineral Rent(as % of GDP) of Morocco?
Offer a terse response. 1.57. In the year 2008, what is the difference between the Mineral Rent(as % of GDP) of Lao PDR and Mineral Rent(as % of GDP) of Vietnam?
Your answer should be very brief. 8.9. In the year 2008, what is the difference between the Mineral Rent(as % of GDP) of Morocco and Mineral Rent(as % of GDP) of Vietnam?
Make the answer very short. 7.33. In the year 2009, what is the difference between the Mineral Rent(as % of GDP) in World and Mineral Rent(as % of GDP) in Lao PDR?
Your response must be concise. -8.82. In the year 2009, what is the difference between the Mineral Rent(as % of GDP) in World and Mineral Rent(as % of GDP) in Morocco?
Your answer should be compact. -1.28. In the year 2009, what is the difference between the Mineral Rent(as % of GDP) of World and Mineral Rent(as % of GDP) of Vietnam?
Make the answer very short. 0.03. In the year 2009, what is the difference between the Mineral Rent(as % of GDP) of Lao PDR and Mineral Rent(as % of GDP) of Morocco?
Provide a succinct answer. 7.53. In the year 2009, what is the difference between the Mineral Rent(as % of GDP) of Lao PDR and Mineral Rent(as % of GDP) of Vietnam?
Offer a very short reply. 8.84. In the year 2009, what is the difference between the Mineral Rent(as % of GDP) in Morocco and Mineral Rent(as % of GDP) in Vietnam?
Offer a terse response. 1.31. In the year 2010, what is the difference between the Mineral Rent(as % of GDP) of World and Mineral Rent(as % of GDP) of Lao PDR?
Make the answer very short. -12.17. In the year 2010, what is the difference between the Mineral Rent(as % of GDP) of World and Mineral Rent(as % of GDP) of Morocco?
Your response must be concise. -1.72. In the year 2010, what is the difference between the Mineral Rent(as % of GDP) in World and Mineral Rent(as % of GDP) in Vietnam?
Make the answer very short. 0.12. In the year 2010, what is the difference between the Mineral Rent(as % of GDP) of Lao PDR and Mineral Rent(as % of GDP) of Morocco?
Your answer should be very brief. 10.45. In the year 2010, what is the difference between the Mineral Rent(as % of GDP) in Lao PDR and Mineral Rent(as % of GDP) in Vietnam?
Your answer should be very brief. 12.28. In the year 2010, what is the difference between the Mineral Rent(as % of GDP) in Morocco and Mineral Rent(as % of GDP) in Vietnam?
Your response must be concise. 1.83. In the year 2011, what is the difference between the Mineral Rent(as % of GDP) in World and Mineral Rent(as % of GDP) in Lao PDR?
Provide a short and direct response. -13.35. In the year 2011, what is the difference between the Mineral Rent(as % of GDP) in World and Mineral Rent(as % of GDP) in Morocco?
Your answer should be very brief. -3.2. In the year 2011, what is the difference between the Mineral Rent(as % of GDP) of World and Mineral Rent(as % of GDP) of Vietnam?
Offer a very short reply. 0.13. In the year 2011, what is the difference between the Mineral Rent(as % of GDP) of Lao PDR and Mineral Rent(as % of GDP) of Morocco?
Keep it short and to the point. 10.15. In the year 2011, what is the difference between the Mineral Rent(as % of GDP) in Lao PDR and Mineral Rent(as % of GDP) in Vietnam?
Offer a terse response. 13.48. In the year 2011, what is the difference between the Mineral Rent(as % of GDP) in Morocco and Mineral Rent(as % of GDP) in Vietnam?
Make the answer very short. 3.33. In the year 2012, what is the difference between the Mineral Rent(as % of GDP) in World and Mineral Rent(as % of GDP) in Lao PDR?
Keep it short and to the point. -11.95. In the year 2012, what is the difference between the Mineral Rent(as % of GDP) of World and Mineral Rent(as % of GDP) of Morocco?
Your answer should be very brief. -3.53. In the year 2012, what is the difference between the Mineral Rent(as % of GDP) in World and Mineral Rent(as % of GDP) in Vietnam?
Provide a short and direct response. 0.17. In the year 2012, what is the difference between the Mineral Rent(as % of GDP) in Lao PDR and Mineral Rent(as % of GDP) in Morocco?
Offer a terse response. 8.42. In the year 2012, what is the difference between the Mineral Rent(as % of GDP) of Lao PDR and Mineral Rent(as % of GDP) of Vietnam?
Provide a succinct answer. 12.12. In the year 2012, what is the difference between the Mineral Rent(as % of GDP) in Morocco and Mineral Rent(as % of GDP) in Vietnam?
Your answer should be compact. 3.69. In the year 2013, what is the difference between the Mineral Rent(as % of GDP) in World and Mineral Rent(as % of GDP) in Lao PDR?
Your answer should be compact. -9.57. In the year 2013, what is the difference between the Mineral Rent(as % of GDP) in World and Mineral Rent(as % of GDP) in Morocco?
Offer a very short reply. -2.35. In the year 2013, what is the difference between the Mineral Rent(as % of GDP) of World and Mineral Rent(as % of GDP) of Vietnam?
Offer a very short reply. 0.21. In the year 2013, what is the difference between the Mineral Rent(as % of GDP) of Lao PDR and Mineral Rent(as % of GDP) of Morocco?
Provide a succinct answer. 7.22. In the year 2013, what is the difference between the Mineral Rent(as % of GDP) in Lao PDR and Mineral Rent(as % of GDP) in Vietnam?
Your answer should be very brief. 9.77. In the year 2013, what is the difference between the Mineral Rent(as % of GDP) in Morocco and Mineral Rent(as % of GDP) in Vietnam?
Offer a terse response. 2.56. What is the ratio of the Mineral Rent(as % of GDP) of World in 2006 to that in 2007?
Provide a succinct answer. 0.68. What is the ratio of the Mineral Rent(as % of GDP) in Lao PDR in 2006 to that in 2007?
Ensure brevity in your answer.  1.12. What is the ratio of the Mineral Rent(as % of GDP) in Morocco in 2006 to that in 2007?
Your answer should be compact. 0.42. What is the ratio of the Mineral Rent(as % of GDP) in Vietnam in 2006 to that in 2007?
Offer a terse response. 0.57. What is the ratio of the Mineral Rent(as % of GDP) of World in 2006 to that in 2008?
Ensure brevity in your answer.  0.61. What is the ratio of the Mineral Rent(as % of GDP) of Lao PDR in 2006 to that in 2008?
Make the answer very short. 1.1. What is the ratio of the Mineral Rent(as % of GDP) of Morocco in 2006 to that in 2008?
Ensure brevity in your answer.  0.07. What is the ratio of the Mineral Rent(as % of GDP) in Vietnam in 2006 to that in 2008?
Provide a short and direct response. 0.25. What is the ratio of the Mineral Rent(as % of GDP) in World in 2006 to that in 2009?
Keep it short and to the point. 1.05. What is the ratio of the Mineral Rent(as % of GDP) in Lao PDR in 2006 to that in 2009?
Your answer should be very brief. 1.19. What is the ratio of the Mineral Rent(as % of GDP) in Morocco in 2006 to that in 2009?
Your response must be concise. 0.34. What is the ratio of the Mineral Rent(as % of GDP) of Vietnam in 2006 to that in 2009?
Your answer should be very brief. 0.66. What is the ratio of the Mineral Rent(as % of GDP) of World in 2006 to that in 2010?
Give a very brief answer. 0.58. What is the ratio of the Mineral Rent(as % of GDP) in Lao PDR in 2006 to that in 2010?
Your answer should be compact. 0.85. What is the ratio of the Mineral Rent(as % of GDP) of Morocco in 2006 to that in 2010?
Provide a short and direct response. 0.23. What is the ratio of the Mineral Rent(as % of GDP) of Vietnam in 2006 to that in 2010?
Provide a short and direct response. 0.4. What is the ratio of the Mineral Rent(as % of GDP) of World in 2006 to that in 2011?
Provide a succinct answer. 0.48. What is the ratio of the Mineral Rent(as % of GDP) of Lao PDR in 2006 to that in 2011?
Provide a succinct answer. 0.77. What is the ratio of the Mineral Rent(as % of GDP) in Morocco in 2006 to that in 2011?
Make the answer very short. 0.14. What is the ratio of the Mineral Rent(as % of GDP) in Vietnam in 2006 to that in 2011?
Ensure brevity in your answer.  0.33. What is the ratio of the Mineral Rent(as % of GDP) in World in 2006 to that in 2012?
Give a very brief answer. 0.6. What is the ratio of the Mineral Rent(as % of GDP) in Lao PDR in 2006 to that in 2012?
Give a very brief answer. 0.86. What is the ratio of the Mineral Rent(as % of GDP) in Morocco in 2006 to that in 2012?
Ensure brevity in your answer.  0.14. What is the ratio of the Mineral Rent(as % of GDP) in Vietnam in 2006 to that in 2012?
Ensure brevity in your answer.  0.45. What is the ratio of the Mineral Rent(as % of GDP) of World in 2006 to that in 2013?
Your answer should be very brief. 0.63. What is the ratio of the Mineral Rent(as % of GDP) of Lao PDR in 2006 to that in 2013?
Offer a very short reply. 1.06. What is the ratio of the Mineral Rent(as % of GDP) of Morocco in 2006 to that in 2013?
Offer a very short reply. 0.19. What is the ratio of the Mineral Rent(as % of GDP) in Vietnam in 2006 to that in 2013?
Offer a terse response. 0.51. What is the ratio of the Mineral Rent(as % of GDP) in World in 2007 to that in 2008?
Offer a very short reply. 0.9. What is the ratio of the Mineral Rent(as % of GDP) in Lao PDR in 2007 to that in 2008?
Keep it short and to the point. 0.98. What is the ratio of the Mineral Rent(as % of GDP) of Morocco in 2007 to that in 2008?
Offer a terse response. 0.16. What is the ratio of the Mineral Rent(as % of GDP) of Vietnam in 2007 to that in 2008?
Your answer should be compact. 0.44. What is the ratio of the Mineral Rent(as % of GDP) of World in 2007 to that in 2009?
Your answer should be compact. 1.56. What is the ratio of the Mineral Rent(as % of GDP) in Lao PDR in 2007 to that in 2009?
Your answer should be compact. 1.06. What is the ratio of the Mineral Rent(as % of GDP) in Morocco in 2007 to that in 2009?
Keep it short and to the point. 0.8. What is the ratio of the Mineral Rent(as % of GDP) of Vietnam in 2007 to that in 2009?
Your answer should be very brief. 1.15. What is the ratio of the Mineral Rent(as % of GDP) of World in 2007 to that in 2010?
Provide a succinct answer. 0.85. What is the ratio of the Mineral Rent(as % of GDP) of Lao PDR in 2007 to that in 2010?
Give a very brief answer. 0.76. What is the ratio of the Mineral Rent(as % of GDP) in Morocco in 2007 to that in 2010?
Ensure brevity in your answer.  0.55. What is the ratio of the Mineral Rent(as % of GDP) of Vietnam in 2007 to that in 2010?
Ensure brevity in your answer.  0.69. What is the ratio of the Mineral Rent(as % of GDP) of World in 2007 to that in 2011?
Your response must be concise. 0.72. What is the ratio of the Mineral Rent(as % of GDP) in Lao PDR in 2007 to that in 2011?
Your answer should be compact. 0.69. What is the ratio of the Mineral Rent(as % of GDP) in Morocco in 2007 to that in 2011?
Ensure brevity in your answer.  0.33. What is the ratio of the Mineral Rent(as % of GDP) in Vietnam in 2007 to that in 2011?
Your response must be concise. 0.58. What is the ratio of the Mineral Rent(as % of GDP) in World in 2007 to that in 2012?
Offer a terse response. 0.89. What is the ratio of the Mineral Rent(as % of GDP) in Lao PDR in 2007 to that in 2012?
Offer a very short reply. 0.77. What is the ratio of the Mineral Rent(as % of GDP) in Morocco in 2007 to that in 2012?
Your answer should be compact. 0.32. What is the ratio of the Mineral Rent(as % of GDP) of Vietnam in 2007 to that in 2012?
Offer a very short reply. 0.78. What is the ratio of the Mineral Rent(as % of GDP) of World in 2007 to that in 2013?
Your answer should be very brief. 0.93. What is the ratio of the Mineral Rent(as % of GDP) in Lao PDR in 2007 to that in 2013?
Offer a terse response. 0.95. What is the ratio of the Mineral Rent(as % of GDP) in Morocco in 2007 to that in 2013?
Offer a terse response. 0.45. What is the ratio of the Mineral Rent(as % of GDP) in Vietnam in 2007 to that in 2013?
Make the answer very short. 0.9. What is the ratio of the Mineral Rent(as % of GDP) of World in 2008 to that in 2009?
Your answer should be compact. 1.74. What is the ratio of the Mineral Rent(as % of GDP) of Lao PDR in 2008 to that in 2009?
Your answer should be very brief. 1.08. What is the ratio of the Mineral Rent(as % of GDP) of Morocco in 2008 to that in 2009?
Offer a very short reply. 4.87. What is the ratio of the Mineral Rent(as % of GDP) of Vietnam in 2008 to that in 2009?
Your answer should be very brief. 2.63. What is the ratio of the Mineral Rent(as % of GDP) in World in 2008 to that in 2010?
Make the answer very short. 0.95. What is the ratio of the Mineral Rent(as % of GDP) in Lao PDR in 2008 to that in 2010?
Provide a short and direct response. 0.77. What is the ratio of the Mineral Rent(as % of GDP) of Morocco in 2008 to that in 2010?
Keep it short and to the point. 3.33. What is the ratio of the Mineral Rent(as % of GDP) in Vietnam in 2008 to that in 2010?
Offer a terse response. 1.58. What is the ratio of the Mineral Rent(as % of GDP) in World in 2008 to that in 2011?
Your response must be concise. 0.8. What is the ratio of the Mineral Rent(as % of GDP) in Lao PDR in 2008 to that in 2011?
Provide a short and direct response. 0.7. What is the ratio of the Mineral Rent(as % of GDP) of Morocco in 2008 to that in 2011?
Offer a very short reply. 2.02. What is the ratio of the Mineral Rent(as % of GDP) in Vietnam in 2008 to that in 2011?
Keep it short and to the point. 1.31. What is the ratio of the Mineral Rent(as % of GDP) in World in 2008 to that in 2012?
Your answer should be very brief. 0.99. What is the ratio of the Mineral Rent(as % of GDP) in Lao PDR in 2008 to that in 2012?
Give a very brief answer. 0.79. What is the ratio of the Mineral Rent(as % of GDP) of Morocco in 2008 to that in 2012?
Ensure brevity in your answer.  1.96. What is the ratio of the Mineral Rent(as % of GDP) of Vietnam in 2008 to that in 2012?
Your answer should be compact. 1.79. What is the ratio of the Mineral Rent(as % of GDP) in World in 2008 to that in 2013?
Provide a short and direct response. 1.04. What is the ratio of the Mineral Rent(as % of GDP) in Lao PDR in 2008 to that in 2013?
Provide a short and direct response. 0.97. What is the ratio of the Mineral Rent(as % of GDP) in Morocco in 2008 to that in 2013?
Ensure brevity in your answer.  2.72. What is the ratio of the Mineral Rent(as % of GDP) in Vietnam in 2008 to that in 2013?
Offer a very short reply. 2.05. What is the ratio of the Mineral Rent(as % of GDP) of World in 2009 to that in 2010?
Your answer should be very brief. 0.55. What is the ratio of the Mineral Rent(as % of GDP) in Lao PDR in 2009 to that in 2010?
Provide a succinct answer. 0.71. What is the ratio of the Mineral Rent(as % of GDP) in Morocco in 2009 to that in 2010?
Ensure brevity in your answer.  0.68. What is the ratio of the Mineral Rent(as % of GDP) in Vietnam in 2009 to that in 2010?
Provide a succinct answer. 0.6. What is the ratio of the Mineral Rent(as % of GDP) in World in 2009 to that in 2011?
Your response must be concise. 0.46. What is the ratio of the Mineral Rent(as % of GDP) in Lao PDR in 2009 to that in 2011?
Your answer should be compact. 0.65. What is the ratio of the Mineral Rent(as % of GDP) of Morocco in 2009 to that in 2011?
Provide a succinct answer. 0.41. What is the ratio of the Mineral Rent(as % of GDP) in Vietnam in 2009 to that in 2011?
Provide a short and direct response. 0.5. What is the ratio of the Mineral Rent(as % of GDP) in World in 2009 to that in 2012?
Your response must be concise. 0.57. What is the ratio of the Mineral Rent(as % of GDP) in Lao PDR in 2009 to that in 2012?
Provide a short and direct response. 0.73. What is the ratio of the Mineral Rent(as % of GDP) in Morocco in 2009 to that in 2012?
Ensure brevity in your answer.  0.4. What is the ratio of the Mineral Rent(as % of GDP) of Vietnam in 2009 to that in 2012?
Provide a succinct answer. 0.68. What is the ratio of the Mineral Rent(as % of GDP) of World in 2009 to that in 2013?
Keep it short and to the point. 0.6. What is the ratio of the Mineral Rent(as % of GDP) in Lao PDR in 2009 to that in 2013?
Give a very brief answer. 0.9. What is the ratio of the Mineral Rent(as % of GDP) in Morocco in 2009 to that in 2013?
Make the answer very short. 0.56. What is the ratio of the Mineral Rent(as % of GDP) of Vietnam in 2009 to that in 2013?
Provide a short and direct response. 0.78. What is the ratio of the Mineral Rent(as % of GDP) in World in 2010 to that in 2011?
Your answer should be very brief. 0.84. What is the ratio of the Mineral Rent(as % of GDP) of Lao PDR in 2010 to that in 2011?
Ensure brevity in your answer.  0.91. What is the ratio of the Mineral Rent(as % of GDP) in Morocco in 2010 to that in 2011?
Provide a short and direct response. 0.61. What is the ratio of the Mineral Rent(as % of GDP) in Vietnam in 2010 to that in 2011?
Keep it short and to the point. 0.83. What is the ratio of the Mineral Rent(as % of GDP) of World in 2010 to that in 2012?
Provide a succinct answer. 1.04. What is the ratio of the Mineral Rent(as % of GDP) in Lao PDR in 2010 to that in 2012?
Provide a succinct answer. 1.02. What is the ratio of the Mineral Rent(as % of GDP) of Morocco in 2010 to that in 2012?
Your answer should be compact. 0.59. What is the ratio of the Mineral Rent(as % of GDP) of Vietnam in 2010 to that in 2012?
Provide a succinct answer. 1.13. What is the ratio of the Mineral Rent(as % of GDP) of World in 2010 to that in 2013?
Keep it short and to the point. 1.09. What is the ratio of the Mineral Rent(as % of GDP) of Lao PDR in 2010 to that in 2013?
Provide a short and direct response. 1.26. What is the ratio of the Mineral Rent(as % of GDP) of Morocco in 2010 to that in 2013?
Offer a terse response. 0.82. What is the ratio of the Mineral Rent(as % of GDP) in Vietnam in 2010 to that in 2013?
Provide a short and direct response. 1.3. What is the ratio of the Mineral Rent(as % of GDP) in World in 2011 to that in 2012?
Your response must be concise. 1.23. What is the ratio of the Mineral Rent(as % of GDP) in Lao PDR in 2011 to that in 2012?
Give a very brief answer. 1.12. What is the ratio of the Mineral Rent(as % of GDP) in Morocco in 2011 to that in 2012?
Make the answer very short. 0.97. What is the ratio of the Mineral Rent(as % of GDP) in Vietnam in 2011 to that in 2012?
Your answer should be very brief. 1.36. What is the ratio of the Mineral Rent(as % of GDP) of World in 2011 to that in 2013?
Provide a succinct answer. 1.3. What is the ratio of the Mineral Rent(as % of GDP) of Lao PDR in 2011 to that in 2013?
Ensure brevity in your answer.  1.39. What is the ratio of the Mineral Rent(as % of GDP) of Morocco in 2011 to that in 2013?
Provide a short and direct response. 1.35. What is the ratio of the Mineral Rent(as % of GDP) in Vietnam in 2011 to that in 2013?
Offer a terse response. 1.56. What is the ratio of the Mineral Rent(as % of GDP) in World in 2012 to that in 2013?
Offer a terse response. 1.05. What is the ratio of the Mineral Rent(as % of GDP) of Lao PDR in 2012 to that in 2013?
Provide a succinct answer. 1.23. What is the ratio of the Mineral Rent(as % of GDP) of Morocco in 2012 to that in 2013?
Ensure brevity in your answer.  1.39. What is the ratio of the Mineral Rent(as % of GDP) in Vietnam in 2012 to that in 2013?
Provide a short and direct response. 1.15. What is the difference between the highest and the second highest Mineral Rent(as % of GDP) of World?
Your answer should be very brief. 0.16. What is the difference between the highest and the second highest Mineral Rent(as % of GDP) of Lao PDR?
Offer a very short reply. 1.34. What is the difference between the highest and the second highest Mineral Rent(as % of GDP) of Morocco?
Keep it short and to the point. 4.13. What is the difference between the highest and the second highest Mineral Rent(as % of GDP) in Vietnam?
Your answer should be compact. 0.27. What is the difference between the highest and the lowest Mineral Rent(as % of GDP) in World?
Offer a very short reply. 0.53. What is the difference between the highest and the lowest Mineral Rent(as % of GDP) of Lao PDR?
Your response must be concise. 5.06. What is the difference between the highest and the lowest Mineral Rent(as % of GDP) in Morocco?
Give a very brief answer. 7.86. What is the difference between the highest and the lowest Mineral Rent(as % of GDP) of Vietnam?
Make the answer very short. 0.84. 